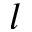<formula> <loc_0><loc_0><loc_500><loc_500>l</formula> 